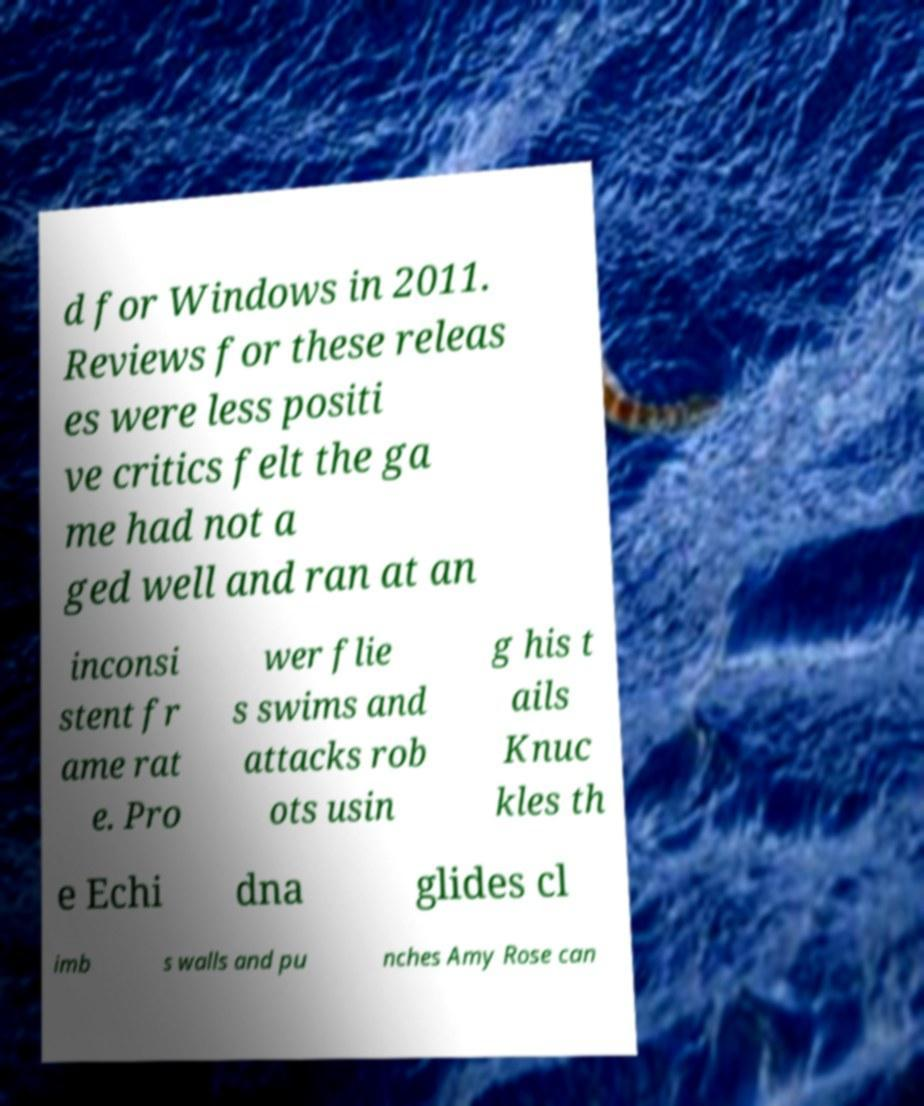Can you read and provide the text displayed in the image?This photo seems to have some interesting text. Can you extract and type it out for me? d for Windows in 2011. Reviews for these releas es were less positi ve critics felt the ga me had not a ged well and ran at an inconsi stent fr ame rat e. Pro wer flie s swims and attacks rob ots usin g his t ails Knuc kles th e Echi dna glides cl imb s walls and pu nches Amy Rose can 